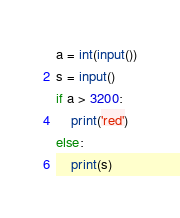Convert code to text. <code><loc_0><loc_0><loc_500><loc_500><_Python_>a = int(input())
s = input()
if a > 3200:
    print('red')
else:
    print(s)</code> 